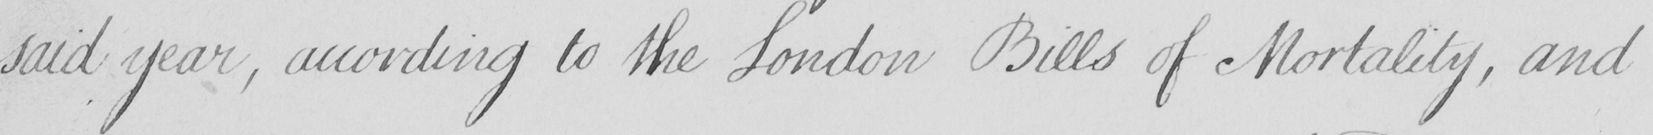Can you tell me what this handwritten text says? said year , according to the London Bills of Mortality , and 